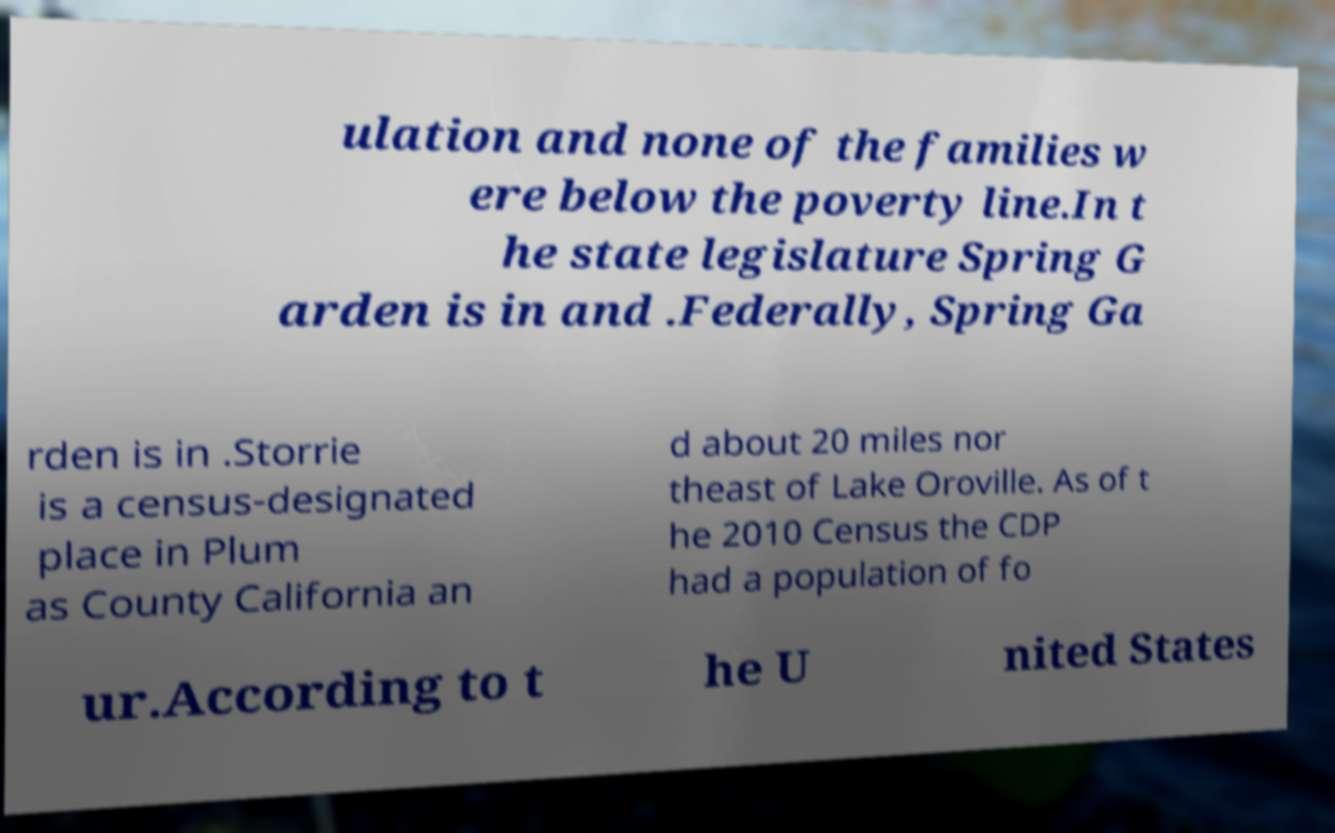Please read and relay the text visible in this image. What does it say? ulation and none of the families w ere below the poverty line.In t he state legislature Spring G arden is in and .Federally, Spring Ga rden is in .Storrie is a census-designated place in Plum as County California an d about 20 miles nor theast of Lake Oroville. As of t he 2010 Census the CDP had a population of fo ur.According to t he U nited States 